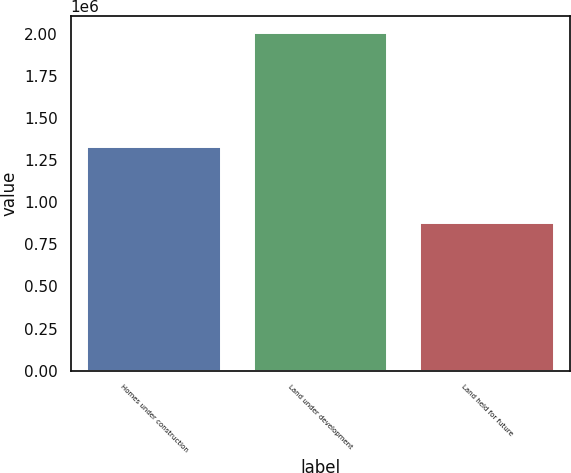Convert chart to OTSL. <chart><loc_0><loc_0><loc_500><loc_500><bar_chart><fcel>Homes under construction<fcel>Land under development<fcel>Land held for future<nl><fcel>1.32567e+06<fcel>2.00204e+06<fcel>873578<nl></chart> 